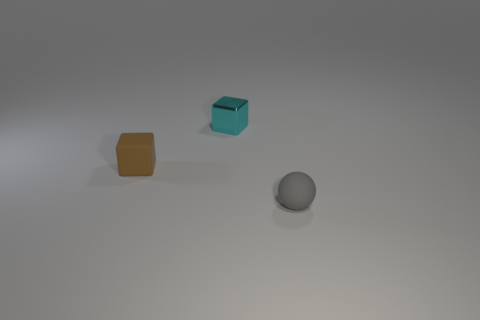Add 1 tiny cyan metallic things. How many objects exist? 4 Subtract 1 blocks. How many blocks are left? 1 Subtract all balls. How many objects are left? 2 Add 1 rubber cubes. How many rubber cubes are left? 2 Add 2 purple metal cylinders. How many purple metal cylinders exist? 2 Subtract 0 red cylinders. How many objects are left? 3 Subtract all blue spheres. Subtract all green cylinders. How many spheres are left? 1 Subtract all tiny cyan blocks. Subtract all small brown cubes. How many objects are left? 1 